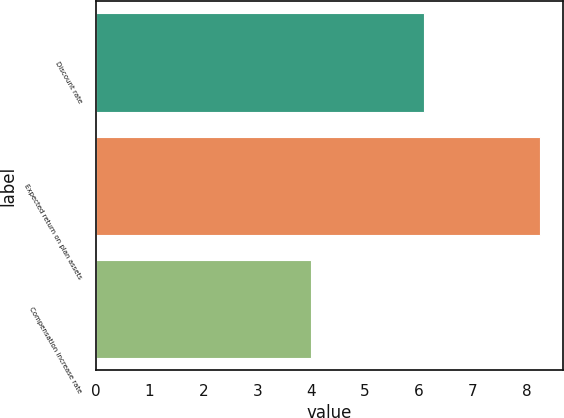Convert chart. <chart><loc_0><loc_0><loc_500><loc_500><bar_chart><fcel>Discount rate<fcel>Expected return on plan assets<fcel>Compensation increase rate<nl><fcel>6.1<fcel>8.25<fcel>4<nl></chart> 